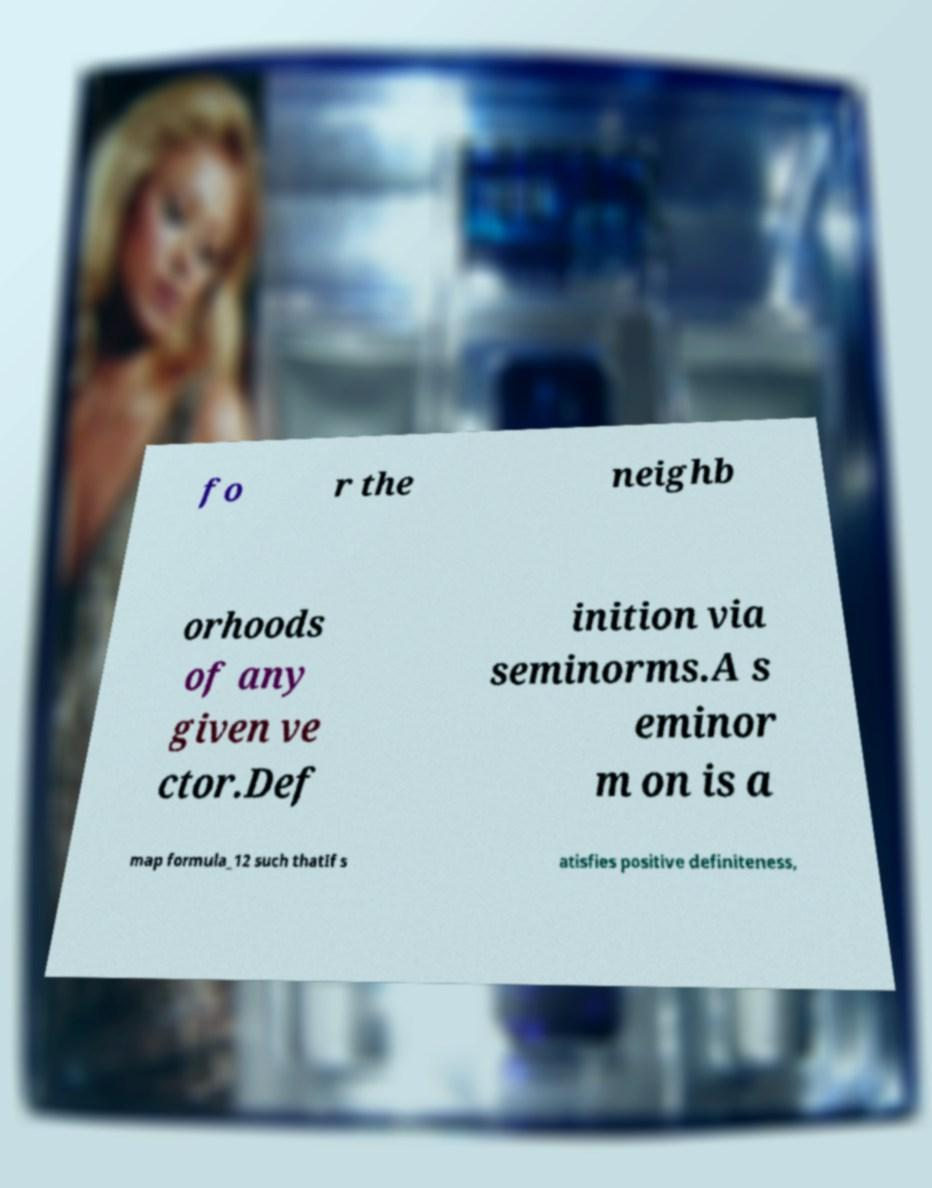Please identify and transcribe the text found in this image. fo r the neighb orhoods of any given ve ctor.Def inition via seminorms.A s eminor m on is a map formula_12 such thatIf s atisfies positive definiteness, 